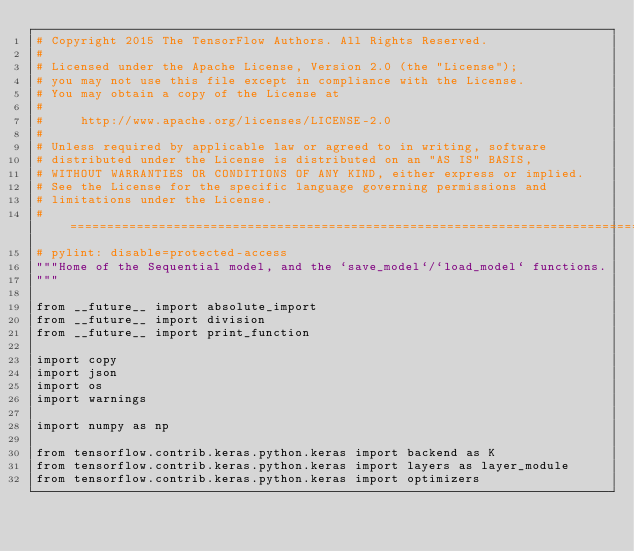Convert code to text. <code><loc_0><loc_0><loc_500><loc_500><_Python_># Copyright 2015 The TensorFlow Authors. All Rights Reserved.
#
# Licensed under the Apache License, Version 2.0 (the "License");
# you may not use this file except in compliance with the License.
# You may obtain a copy of the License at
#
#     http://www.apache.org/licenses/LICENSE-2.0
#
# Unless required by applicable law or agreed to in writing, software
# distributed under the License is distributed on an "AS IS" BASIS,
# WITHOUT WARRANTIES OR CONDITIONS OF ANY KIND, either express or implied.
# See the License for the specific language governing permissions and
# limitations under the License.
# ==============================================================================
# pylint: disable=protected-access
"""Home of the Sequential model, and the `save_model`/`load_model` functions.
"""

from __future__ import absolute_import
from __future__ import division
from __future__ import print_function

import copy
import json
import os
import warnings

import numpy as np

from tensorflow.contrib.keras.python.keras import backend as K
from tensorflow.contrib.keras.python.keras import layers as layer_module
from tensorflow.contrib.keras.python.keras import optimizers</code> 